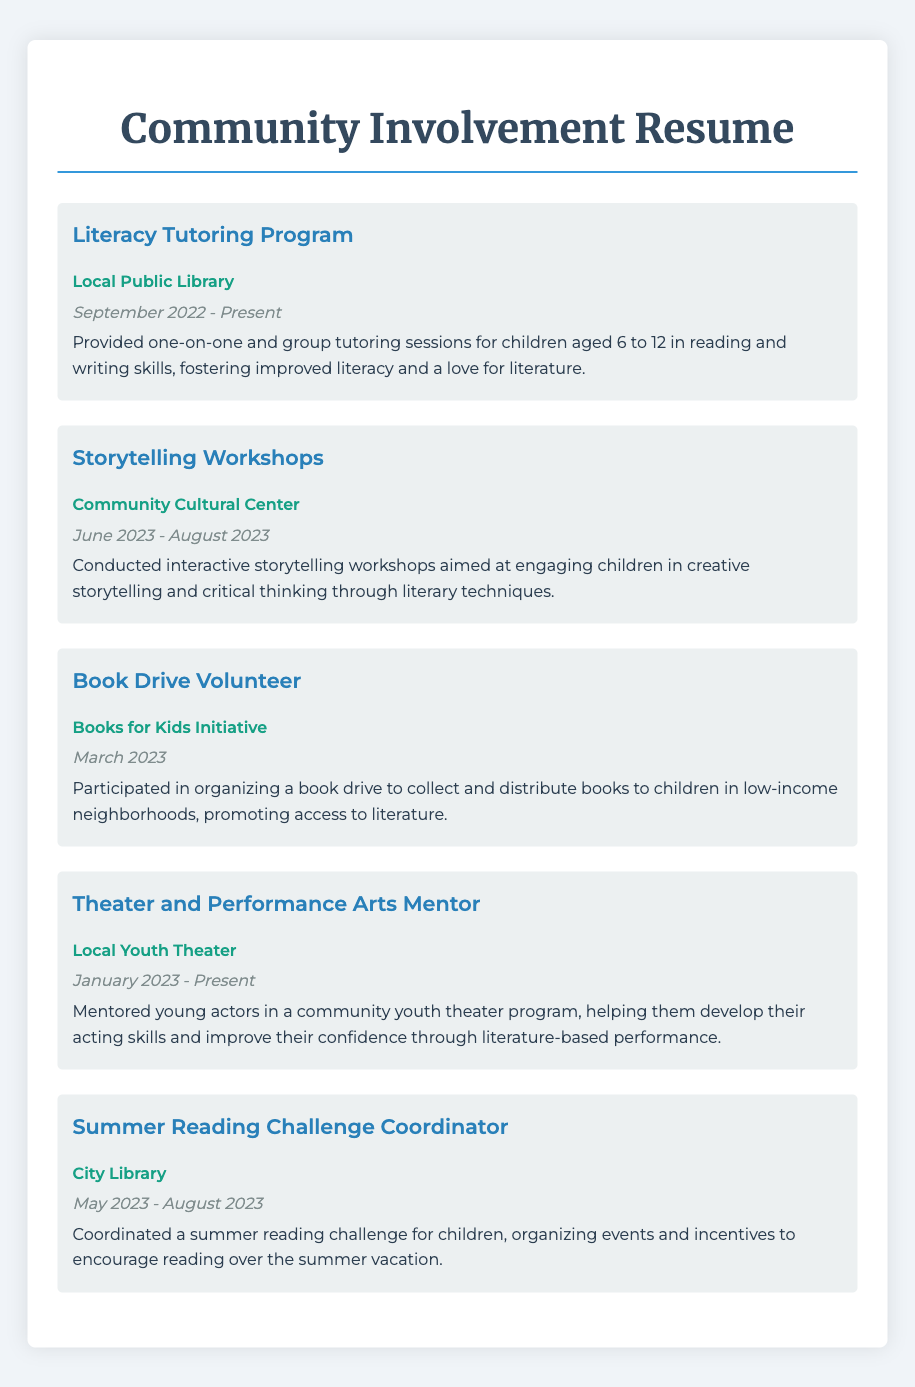What is the title of the document? The title of the document is indicated at the top of the rendered page, which is "Community Involvement Resume."
Answer: Community Involvement Resume Who conducted the storytelling workshops? The workshops were conducted at the Community Cultural Center, indicating the responsible organization.
Answer: Community Cultural Center When did the Book Drive Volunteer participation take place? The document specifies the participation date for the book drive as March 2023.
Answer: March 2023 What is the duration of the Literacy Tutoring Program? The document lists the duration of the program from September 2022 to Present.
Answer: September 2022 - Present What role does the person have at the Local Youth Theater? The document describes the person's role as a mentor in the youth theater program.
Answer: Mentor How long did the Summer Reading Challenge Coordinator position last? The duration of this position is indicated as May 2023 - August 2023.
Answer: May 2023 - August 2023 What is the main goal of the Book Drive Volunteer activity? The goal of this activity is mentioned as promoting access to literature for children in low-income neighborhoods.
Answer: Promoting access to literature Which age group does the Literacy Tutoring Program serve? The document specifies that the program serves children aged 6 to 12.
Answer: Aged 6 to 12 What type of workshops were conducted in the summer of 2023? The document indicates that storytelling workshops were conducted during this time.
Answer: Storytelling workshops 